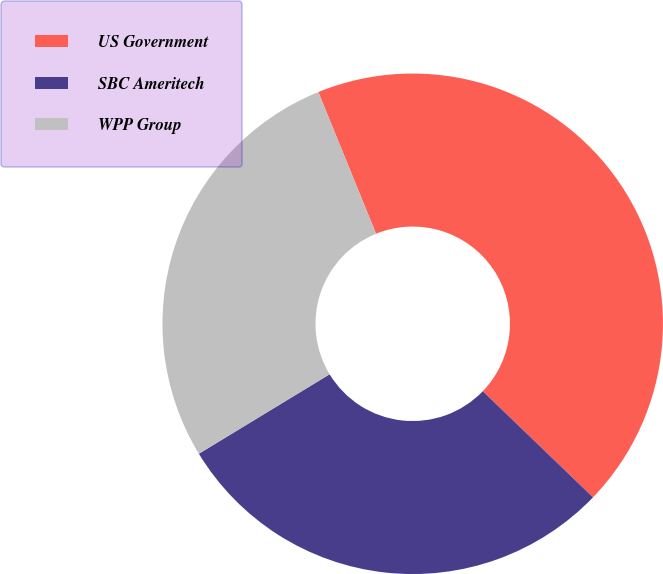<chart> <loc_0><loc_0><loc_500><loc_500><pie_chart><fcel>US Government<fcel>SBC Ameritech<fcel>WPP Group<nl><fcel>43.35%<fcel>29.11%<fcel>27.53%<nl></chart> 